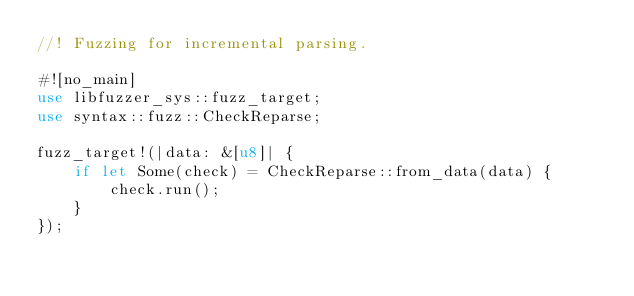Convert code to text. <code><loc_0><loc_0><loc_500><loc_500><_Rust_>//! Fuzzing for incremental parsing.

#![no_main]
use libfuzzer_sys::fuzz_target;
use syntax::fuzz::CheckReparse;

fuzz_target!(|data: &[u8]| {
    if let Some(check) = CheckReparse::from_data(data) {
        check.run();
    }
});
</code> 